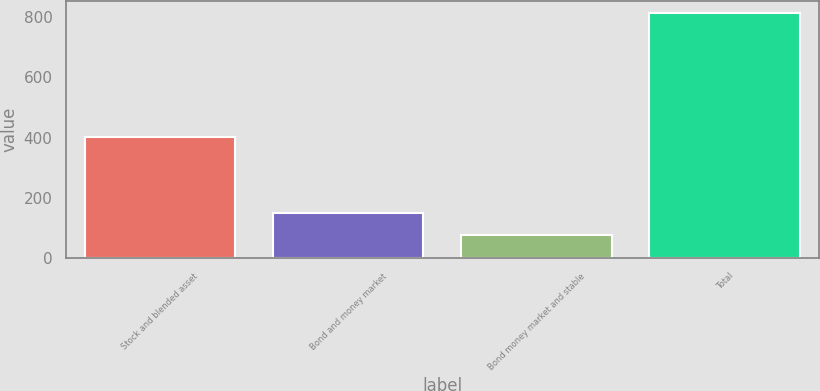<chart> <loc_0><loc_0><loc_500><loc_500><bar_chart><fcel>Stock and blended asset<fcel>Bond and money market<fcel>Bond money market and stable<fcel>Total<nl><fcel>401.3<fcel>149.3<fcel>75.8<fcel>810.8<nl></chart> 